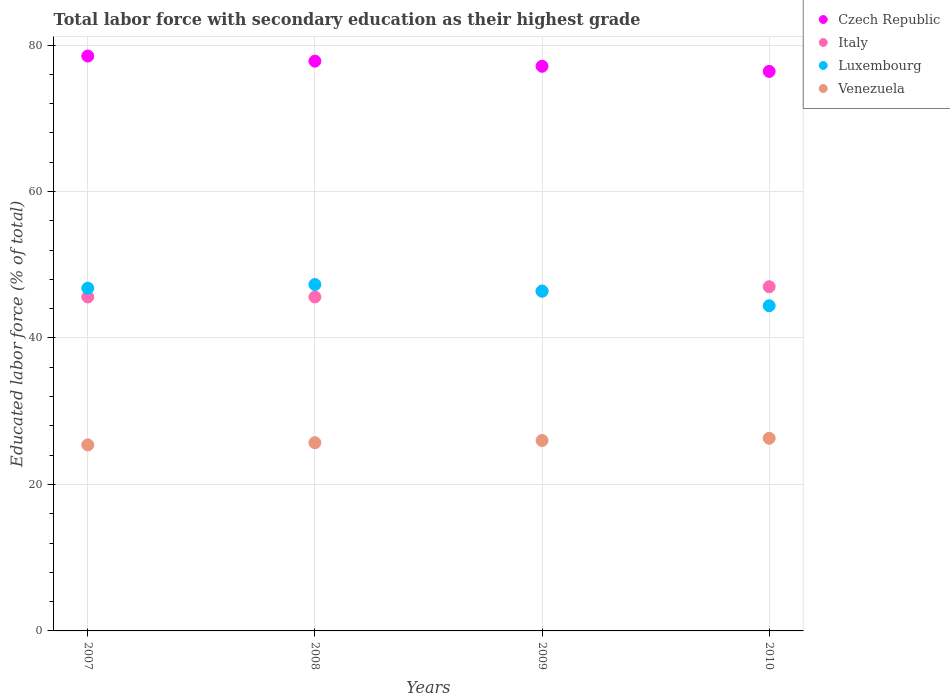How many different coloured dotlines are there?
Your response must be concise. 4. Is the number of dotlines equal to the number of legend labels?
Your answer should be compact. Yes. What is the percentage of total labor force with primary education in Italy in 2007?
Provide a succinct answer. 45.6. Across all years, what is the minimum percentage of total labor force with primary education in Italy?
Ensure brevity in your answer.  45.6. In which year was the percentage of total labor force with primary education in Luxembourg maximum?
Your answer should be very brief. 2008. In which year was the percentage of total labor force with primary education in Luxembourg minimum?
Provide a short and direct response. 2010. What is the total percentage of total labor force with primary education in Venezuela in the graph?
Your answer should be very brief. 103.4. What is the difference between the percentage of total labor force with primary education in Italy in 2007 and that in 2009?
Make the answer very short. -0.8. What is the difference between the percentage of total labor force with primary education in Czech Republic in 2007 and the percentage of total labor force with primary education in Luxembourg in 2008?
Provide a short and direct response. 31.2. What is the average percentage of total labor force with primary education in Luxembourg per year?
Ensure brevity in your answer.  46.23. In the year 2009, what is the difference between the percentage of total labor force with primary education in Italy and percentage of total labor force with primary education in Venezuela?
Offer a terse response. 20.4. What is the ratio of the percentage of total labor force with primary education in Venezuela in 2007 to that in 2009?
Your response must be concise. 0.98. What is the difference between the highest and the second highest percentage of total labor force with primary education in Venezuela?
Offer a terse response. 0.3. What is the difference between the highest and the lowest percentage of total labor force with primary education in Venezuela?
Keep it short and to the point. 0.9. Is it the case that in every year, the sum of the percentage of total labor force with primary education in Italy and percentage of total labor force with primary education in Venezuela  is greater than the sum of percentage of total labor force with primary education in Czech Republic and percentage of total labor force with primary education in Luxembourg?
Ensure brevity in your answer.  Yes. Is the percentage of total labor force with primary education in Czech Republic strictly less than the percentage of total labor force with primary education in Italy over the years?
Give a very brief answer. No. How many years are there in the graph?
Your response must be concise. 4. Does the graph contain any zero values?
Your response must be concise. No. What is the title of the graph?
Keep it short and to the point. Total labor force with secondary education as their highest grade. What is the label or title of the Y-axis?
Provide a succinct answer. Educated labor force (% of total). What is the Educated labor force (% of total) in Czech Republic in 2007?
Keep it short and to the point. 78.5. What is the Educated labor force (% of total) in Italy in 2007?
Give a very brief answer. 45.6. What is the Educated labor force (% of total) in Luxembourg in 2007?
Provide a short and direct response. 46.8. What is the Educated labor force (% of total) in Venezuela in 2007?
Your answer should be compact. 25.4. What is the Educated labor force (% of total) in Czech Republic in 2008?
Provide a succinct answer. 77.8. What is the Educated labor force (% of total) of Italy in 2008?
Offer a very short reply. 45.6. What is the Educated labor force (% of total) in Luxembourg in 2008?
Keep it short and to the point. 47.3. What is the Educated labor force (% of total) in Venezuela in 2008?
Provide a short and direct response. 25.7. What is the Educated labor force (% of total) of Czech Republic in 2009?
Ensure brevity in your answer.  77.1. What is the Educated labor force (% of total) in Italy in 2009?
Provide a short and direct response. 46.4. What is the Educated labor force (% of total) in Luxembourg in 2009?
Provide a succinct answer. 46.4. What is the Educated labor force (% of total) in Czech Republic in 2010?
Your response must be concise. 76.4. What is the Educated labor force (% of total) of Italy in 2010?
Make the answer very short. 47. What is the Educated labor force (% of total) in Luxembourg in 2010?
Give a very brief answer. 44.4. What is the Educated labor force (% of total) in Venezuela in 2010?
Ensure brevity in your answer.  26.3. Across all years, what is the maximum Educated labor force (% of total) of Czech Republic?
Your response must be concise. 78.5. Across all years, what is the maximum Educated labor force (% of total) in Luxembourg?
Your answer should be very brief. 47.3. Across all years, what is the maximum Educated labor force (% of total) in Venezuela?
Make the answer very short. 26.3. Across all years, what is the minimum Educated labor force (% of total) of Czech Republic?
Keep it short and to the point. 76.4. Across all years, what is the minimum Educated labor force (% of total) in Italy?
Provide a short and direct response. 45.6. Across all years, what is the minimum Educated labor force (% of total) of Luxembourg?
Your answer should be very brief. 44.4. Across all years, what is the minimum Educated labor force (% of total) of Venezuela?
Provide a short and direct response. 25.4. What is the total Educated labor force (% of total) of Czech Republic in the graph?
Your response must be concise. 309.8. What is the total Educated labor force (% of total) of Italy in the graph?
Your answer should be compact. 184.6. What is the total Educated labor force (% of total) of Luxembourg in the graph?
Give a very brief answer. 184.9. What is the total Educated labor force (% of total) in Venezuela in the graph?
Offer a terse response. 103.4. What is the difference between the Educated labor force (% of total) of Italy in 2007 and that in 2008?
Ensure brevity in your answer.  0. What is the difference between the Educated labor force (% of total) of Luxembourg in 2007 and that in 2008?
Offer a terse response. -0.5. What is the difference between the Educated labor force (% of total) of Venezuela in 2007 and that in 2009?
Provide a succinct answer. -0.6. What is the difference between the Educated labor force (% of total) in Czech Republic in 2007 and that in 2010?
Keep it short and to the point. 2.1. What is the difference between the Educated labor force (% of total) of Italy in 2007 and that in 2010?
Your response must be concise. -1.4. What is the difference between the Educated labor force (% of total) in Luxembourg in 2007 and that in 2010?
Keep it short and to the point. 2.4. What is the difference between the Educated labor force (% of total) in Venezuela in 2007 and that in 2010?
Provide a succinct answer. -0.9. What is the difference between the Educated labor force (% of total) in Czech Republic in 2008 and that in 2009?
Keep it short and to the point. 0.7. What is the difference between the Educated labor force (% of total) of Venezuela in 2008 and that in 2009?
Your answer should be very brief. -0.3. What is the difference between the Educated labor force (% of total) of Italy in 2008 and that in 2010?
Give a very brief answer. -1.4. What is the difference between the Educated labor force (% of total) in Luxembourg in 2008 and that in 2010?
Give a very brief answer. 2.9. What is the difference between the Educated labor force (% of total) in Venezuela in 2008 and that in 2010?
Ensure brevity in your answer.  -0.6. What is the difference between the Educated labor force (% of total) in Luxembourg in 2009 and that in 2010?
Provide a short and direct response. 2. What is the difference between the Educated labor force (% of total) in Czech Republic in 2007 and the Educated labor force (% of total) in Italy in 2008?
Your answer should be compact. 32.9. What is the difference between the Educated labor force (% of total) in Czech Republic in 2007 and the Educated labor force (% of total) in Luxembourg in 2008?
Your answer should be very brief. 31.2. What is the difference between the Educated labor force (% of total) in Czech Republic in 2007 and the Educated labor force (% of total) in Venezuela in 2008?
Provide a succinct answer. 52.8. What is the difference between the Educated labor force (% of total) in Italy in 2007 and the Educated labor force (% of total) in Venezuela in 2008?
Your response must be concise. 19.9. What is the difference between the Educated labor force (% of total) of Luxembourg in 2007 and the Educated labor force (% of total) of Venezuela in 2008?
Ensure brevity in your answer.  21.1. What is the difference between the Educated labor force (% of total) of Czech Republic in 2007 and the Educated labor force (% of total) of Italy in 2009?
Offer a very short reply. 32.1. What is the difference between the Educated labor force (% of total) in Czech Republic in 2007 and the Educated labor force (% of total) in Luxembourg in 2009?
Provide a short and direct response. 32.1. What is the difference between the Educated labor force (% of total) in Czech Republic in 2007 and the Educated labor force (% of total) in Venezuela in 2009?
Provide a succinct answer. 52.5. What is the difference between the Educated labor force (% of total) in Italy in 2007 and the Educated labor force (% of total) in Venezuela in 2009?
Offer a very short reply. 19.6. What is the difference between the Educated labor force (% of total) in Luxembourg in 2007 and the Educated labor force (% of total) in Venezuela in 2009?
Give a very brief answer. 20.8. What is the difference between the Educated labor force (% of total) in Czech Republic in 2007 and the Educated labor force (% of total) in Italy in 2010?
Offer a terse response. 31.5. What is the difference between the Educated labor force (% of total) in Czech Republic in 2007 and the Educated labor force (% of total) in Luxembourg in 2010?
Your response must be concise. 34.1. What is the difference between the Educated labor force (% of total) of Czech Republic in 2007 and the Educated labor force (% of total) of Venezuela in 2010?
Give a very brief answer. 52.2. What is the difference between the Educated labor force (% of total) in Italy in 2007 and the Educated labor force (% of total) in Venezuela in 2010?
Provide a short and direct response. 19.3. What is the difference between the Educated labor force (% of total) of Czech Republic in 2008 and the Educated labor force (% of total) of Italy in 2009?
Offer a very short reply. 31.4. What is the difference between the Educated labor force (% of total) of Czech Republic in 2008 and the Educated labor force (% of total) of Luxembourg in 2009?
Make the answer very short. 31.4. What is the difference between the Educated labor force (% of total) in Czech Republic in 2008 and the Educated labor force (% of total) in Venezuela in 2009?
Make the answer very short. 51.8. What is the difference between the Educated labor force (% of total) of Italy in 2008 and the Educated labor force (% of total) of Luxembourg in 2009?
Provide a short and direct response. -0.8. What is the difference between the Educated labor force (% of total) of Italy in 2008 and the Educated labor force (% of total) of Venezuela in 2009?
Give a very brief answer. 19.6. What is the difference between the Educated labor force (% of total) of Luxembourg in 2008 and the Educated labor force (% of total) of Venezuela in 2009?
Your answer should be compact. 21.3. What is the difference between the Educated labor force (% of total) of Czech Republic in 2008 and the Educated labor force (% of total) of Italy in 2010?
Make the answer very short. 30.8. What is the difference between the Educated labor force (% of total) in Czech Republic in 2008 and the Educated labor force (% of total) in Luxembourg in 2010?
Make the answer very short. 33.4. What is the difference between the Educated labor force (% of total) of Czech Republic in 2008 and the Educated labor force (% of total) of Venezuela in 2010?
Your answer should be very brief. 51.5. What is the difference between the Educated labor force (% of total) in Italy in 2008 and the Educated labor force (% of total) in Venezuela in 2010?
Provide a succinct answer. 19.3. What is the difference between the Educated labor force (% of total) in Czech Republic in 2009 and the Educated labor force (% of total) in Italy in 2010?
Your response must be concise. 30.1. What is the difference between the Educated labor force (% of total) in Czech Republic in 2009 and the Educated labor force (% of total) in Luxembourg in 2010?
Provide a succinct answer. 32.7. What is the difference between the Educated labor force (% of total) in Czech Republic in 2009 and the Educated labor force (% of total) in Venezuela in 2010?
Give a very brief answer. 50.8. What is the difference between the Educated labor force (% of total) in Italy in 2009 and the Educated labor force (% of total) in Luxembourg in 2010?
Ensure brevity in your answer.  2. What is the difference between the Educated labor force (% of total) in Italy in 2009 and the Educated labor force (% of total) in Venezuela in 2010?
Provide a short and direct response. 20.1. What is the difference between the Educated labor force (% of total) of Luxembourg in 2009 and the Educated labor force (% of total) of Venezuela in 2010?
Keep it short and to the point. 20.1. What is the average Educated labor force (% of total) in Czech Republic per year?
Keep it short and to the point. 77.45. What is the average Educated labor force (% of total) of Italy per year?
Give a very brief answer. 46.15. What is the average Educated labor force (% of total) in Luxembourg per year?
Your answer should be compact. 46.23. What is the average Educated labor force (% of total) in Venezuela per year?
Your answer should be very brief. 25.85. In the year 2007, what is the difference between the Educated labor force (% of total) of Czech Republic and Educated labor force (% of total) of Italy?
Offer a very short reply. 32.9. In the year 2007, what is the difference between the Educated labor force (% of total) in Czech Republic and Educated labor force (% of total) in Luxembourg?
Give a very brief answer. 31.7. In the year 2007, what is the difference between the Educated labor force (% of total) in Czech Republic and Educated labor force (% of total) in Venezuela?
Give a very brief answer. 53.1. In the year 2007, what is the difference between the Educated labor force (% of total) in Italy and Educated labor force (% of total) in Venezuela?
Your response must be concise. 20.2. In the year 2007, what is the difference between the Educated labor force (% of total) in Luxembourg and Educated labor force (% of total) in Venezuela?
Your answer should be very brief. 21.4. In the year 2008, what is the difference between the Educated labor force (% of total) in Czech Republic and Educated labor force (% of total) in Italy?
Offer a very short reply. 32.2. In the year 2008, what is the difference between the Educated labor force (% of total) in Czech Republic and Educated labor force (% of total) in Luxembourg?
Give a very brief answer. 30.5. In the year 2008, what is the difference between the Educated labor force (% of total) of Czech Republic and Educated labor force (% of total) of Venezuela?
Your response must be concise. 52.1. In the year 2008, what is the difference between the Educated labor force (% of total) of Italy and Educated labor force (% of total) of Venezuela?
Provide a short and direct response. 19.9. In the year 2008, what is the difference between the Educated labor force (% of total) of Luxembourg and Educated labor force (% of total) of Venezuela?
Provide a short and direct response. 21.6. In the year 2009, what is the difference between the Educated labor force (% of total) of Czech Republic and Educated labor force (% of total) of Italy?
Your response must be concise. 30.7. In the year 2009, what is the difference between the Educated labor force (% of total) of Czech Republic and Educated labor force (% of total) of Luxembourg?
Your response must be concise. 30.7. In the year 2009, what is the difference between the Educated labor force (% of total) in Czech Republic and Educated labor force (% of total) in Venezuela?
Give a very brief answer. 51.1. In the year 2009, what is the difference between the Educated labor force (% of total) in Italy and Educated labor force (% of total) in Luxembourg?
Offer a very short reply. 0. In the year 2009, what is the difference between the Educated labor force (% of total) in Italy and Educated labor force (% of total) in Venezuela?
Keep it short and to the point. 20.4. In the year 2009, what is the difference between the Educated labor force (% of total) in Luxembourg and Educated labor force (% of total) in Venezuela?
Make the answer very short. 20.4. In the year 2010, what is the difference between the Educated labor force (% of total) of Czech Republic and Educated labor force (% of total) of Italy?
Provide a short and direct response. 29.4. In the year 2010, what is the difference between the Educated labor force (% of total) in Czech Republic and Educated labor force (% of total) in Venezuela?
Provide a succinct answer. 50.1. In the year 2010, what is the difference between the Educated labor force (% of total) of Italy and Educated labor force (% of total) of Venezuela?
Ensure brevity in your answer.  20.7. What is the ratio of the Educated labor force (% of total) in Italy in 2007 to that in 2008?
Provide a short and direct response. 1. What is the ratio of the Educated labor force (% of total) of Venezuela in 2007 to that in 2008?
Ensure brevity in your answer.  0.99. What is the ratio of the Educated labor force (% of total) in Czech Republic in 2007 to that in 2009?
Make the answer very short. 1.02. What is the ratio of the Educated labor force (% of total) of Italy in 2007 to that in 2009?
Your response must be concise. 0.98. What is the ratio of the Educated labor force (% of total) of Luxembourg in 2007 to that in 2009?
Provide a succinct answer. 1.01. What is the ratio of the Educated labor force (% of total) of Venezuela in 2007 to that in 2009?
Offer a terse response. 0.98. What is the ratio of the Educated labor force (% of total) in Czech Republic in 2007 to that in 2010?
Your answer should be compact. 1.03. What is the ratio of the Educated labor force (% of total) of Italy in 2007 to that in 2010?
Your response must be concise. 0.97. What is the ratio of the Educated labor force (% of total) of Luxembourg in 2007 to that in 2010?
Provide a succinct answer. 1.05. What is the ratio of the Educated labor force (% of total) of Venezuela in 2007 to that in 2010?
Ensure brevity in your answer.  0.97. What is the ratio of the Educated labor force (% of total) of Czech Republic in 2008 to that in 2009?
Offer a very short reply. 1.01. What is the ratio of the Educated labor force (% of total) of Italy in 2008 to that in 2009?
Your response must be concise. 0.98. What is the ratio of the Educated labor force (% of total) of Luxembourg in 2008 to that in 2009?
Make the answer very short. 1.02. What is the ratio of the Educated labor force (% of total) of Venezuela in 2008 to that in 2009?
Provide a succinct answer. 0.99. What is the ratio of the Educated labor force (% of total) of Czech Republic in 2008 to that in 2010?
Your answer should be compact. 1.02. What is the ratio of the Educated labor force (% of total) in Italy in 2008 to that in 2010?
Your answer should be compact. 0.97. What is the ratio of the Educated labor force (% of total) in Luxembourg in 2008 to that in 2010?
Give a very brief answer. 1.07. What is the ratio of the Educated labor force (% of total) in Venezuela in 2008 to that in 2010?
Make the answer very short. 0.98. What is the ratio of the Educated labor force (% of total) in Czech Republic in 2009 to that in 2010?
Give a very brief answer. 1.01. What is the ratio of the Educated labor force (% of total) of Italy in 2009 to that in 2010?
Give a very brief answer. 0.99. What is the ratio of the Educated labor force (% of total) in Luxembourg in 2009 to that in 2010?
Ensure brevity in your answer.  1.04. What is the difference between the highest and the second highest Educated labor force (% of total) in Italy?
Keep it short and to the point. 0.6. What is the difference between the highest and the second highest Educated labor force (% of total) in Luxembourg?
Provide a short and direct response. 0.5. What is the difference between the highest and the lowest Educated labor force (% of total) in Czech Republic?
Offer a very short reply. 2.1. 